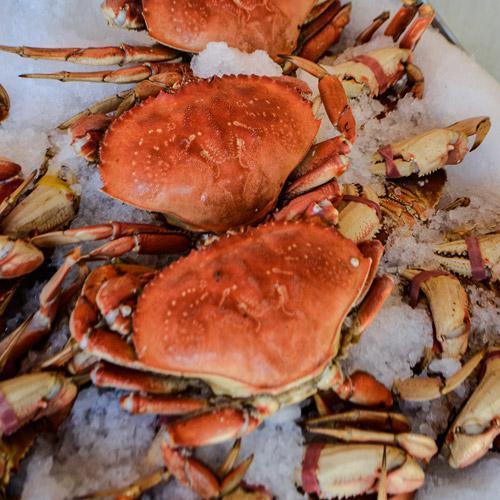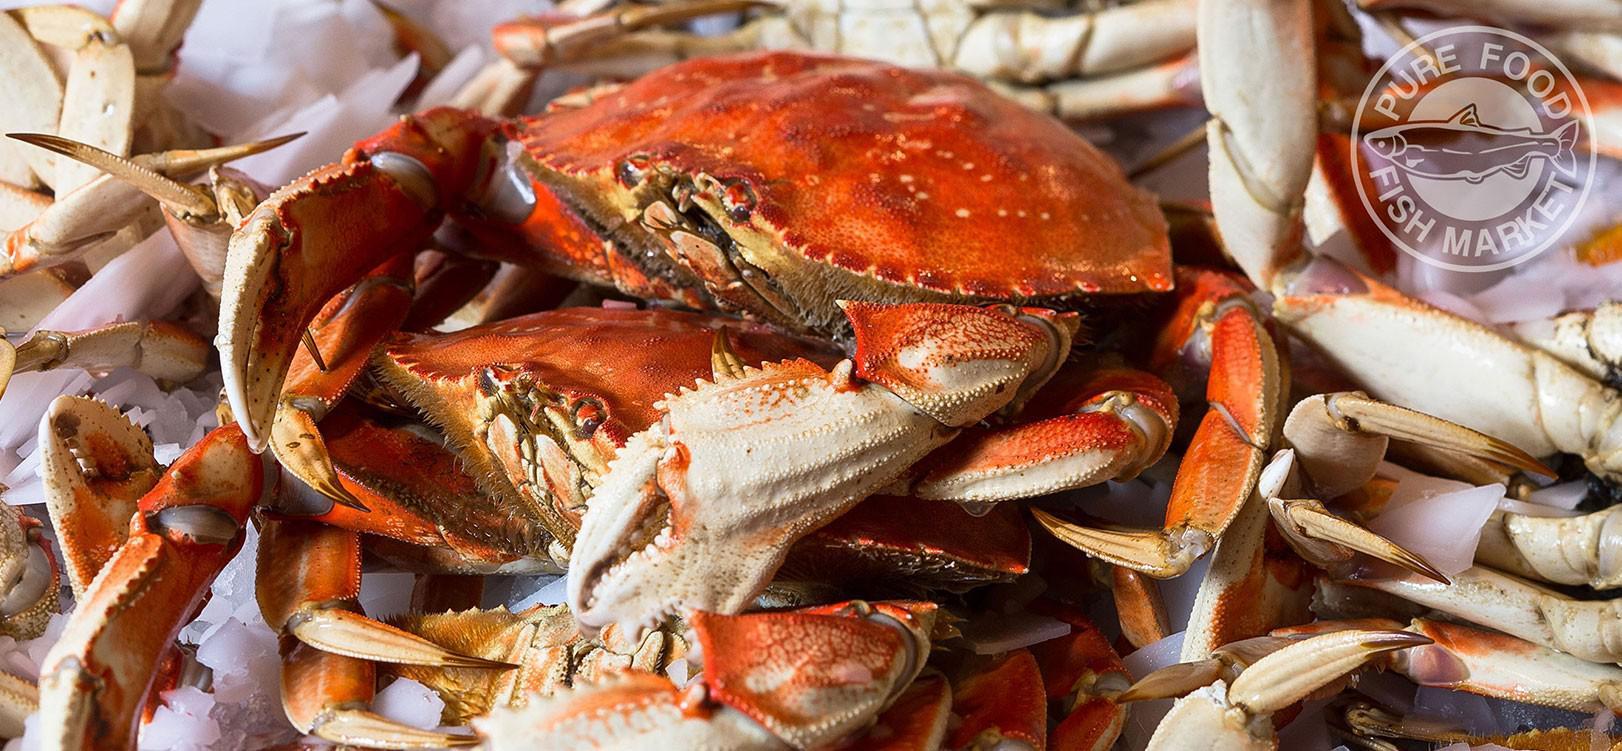The first image is the image on the left, the second image is the image on the right. Analyze the images presented: Is the assertion "A meal of crabs sits near an alcoholic beverage in one of the images." valid? Answer yes or no. No. 